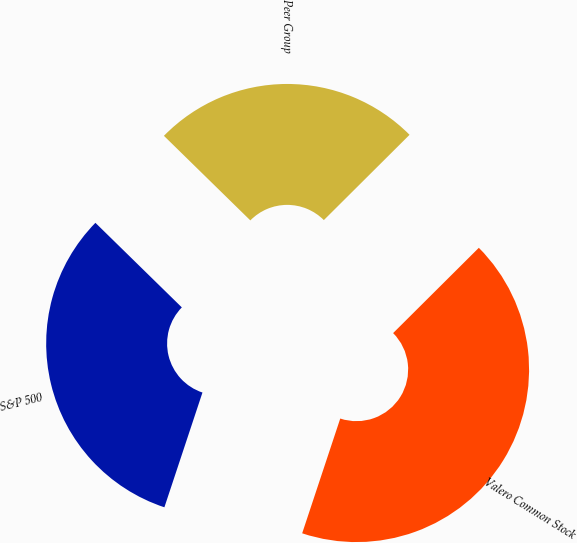<chart> <loc_0><loc_0><loc_500><loc_500><pie_chart><fcel>Valero Common Stock<fcel>S&P 500<fcel>Peer Group<nl><fcel>42.56%<fcel>32.23%<fcel>25.21%<nl></chart> 